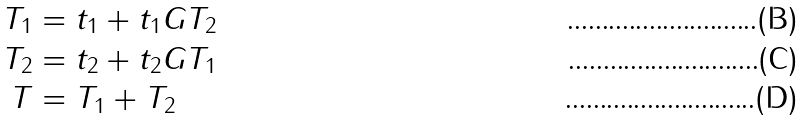<formula> <loc_0><loc_0><loc_500><loc_500>T _ { 1 } & = t _ { 1 } + t _ { 1 } G T _ { 2 } \\ T _ { 2 } & = t _ { 2 } + t _ { 2 } G T _ { 1 } \\ T & = T _ { 1 } + T _ { 2 }</formula> 